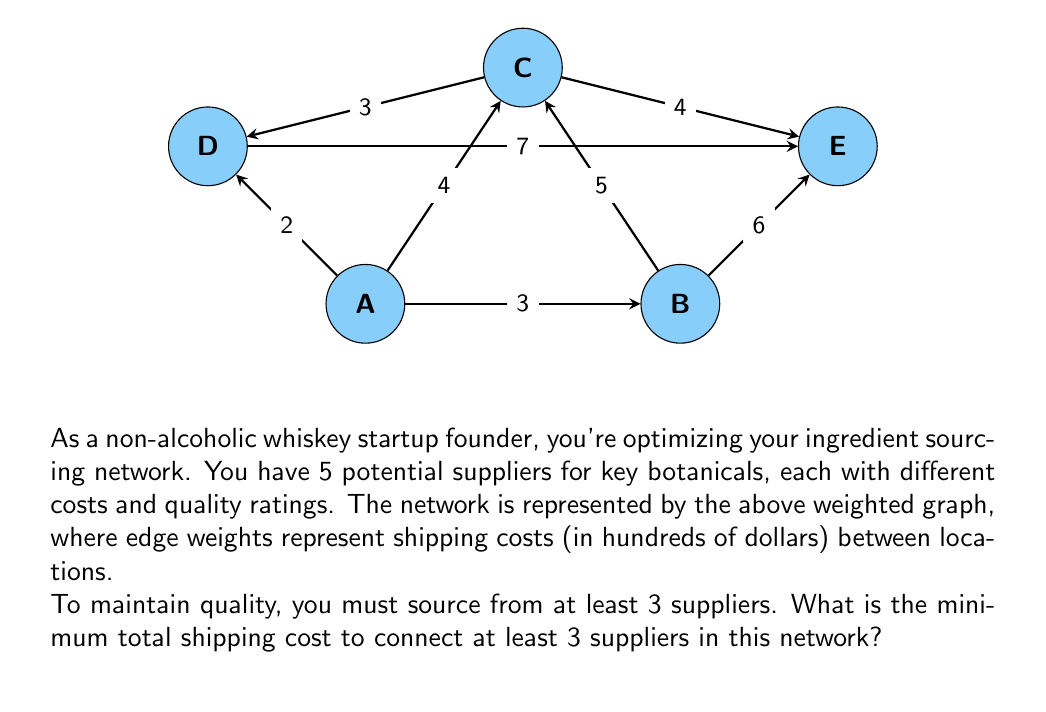Show me your answer to this math problem. To solve this problem, we need to find the minimum spanning tree (MST) that includes at least 3 vertices. Here's a step-by-step approach:

1) First, let's list all edges in order of increasing weight:
   A-D (2), A-B (3), C-D (3), A-C (4), C-E (4), B-C (5), B-E (6), D-E (7)

2) We'll use Kruskal's algorithm to build our MST, but stop when we have connected at least 3 vertices:

   Step 1: Add A-D (2)
   Step 2: Add A-B (3)

   At this point, we have connected 3 vertices (A, B, and D) with a total cost of 5.

3) We can stop here because we've met our condition of connecting at least 3 suppliers.

4) The total shipping cost is the sum of the edge weights: 2 + 3 = 5

5) Converting back to hundreds of dollars, our final answer is $500.

This solution ensures we're sourcing from at least 3 suppliers (A, B, and D) while minimizing the shipping costs.
Answer: $500 